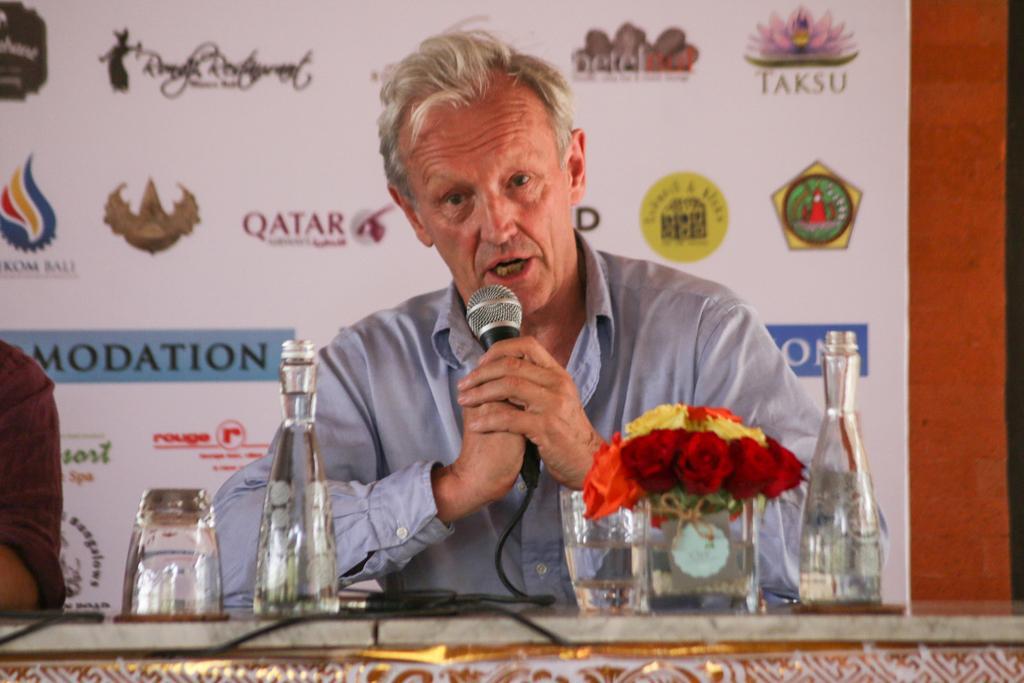Describe this image in one or two sentences. In this image I can see a man holding a mic. On the table there is a glass and a bottle and flower. 